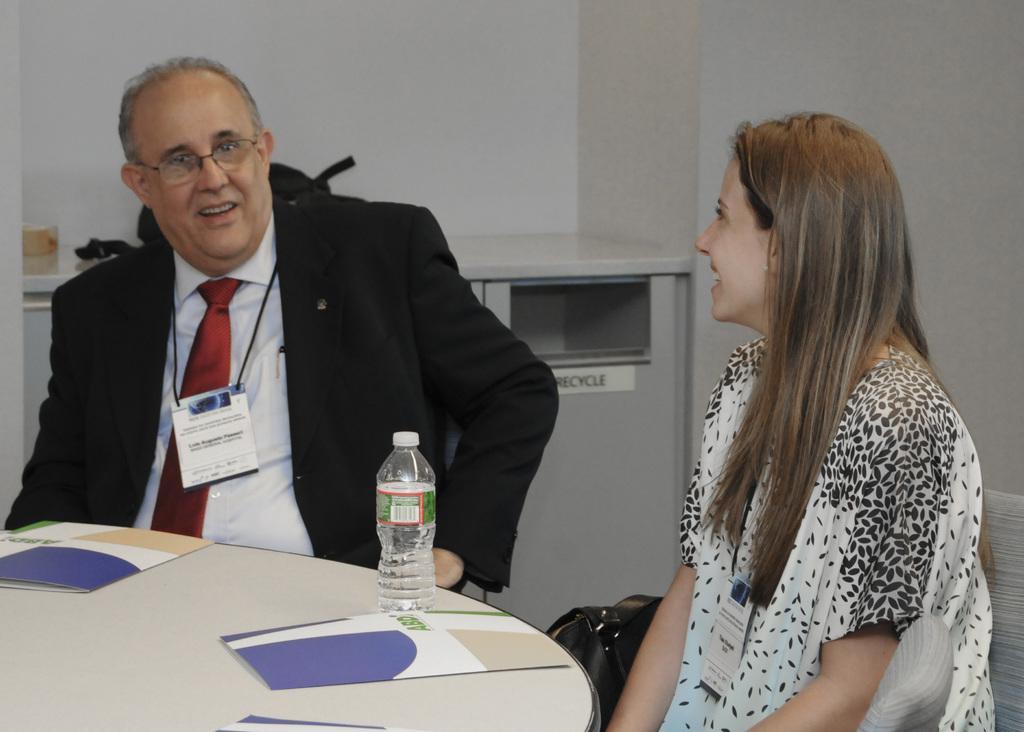Describe this image in one or two sentences. In this image there is a person sitting on chair is wearing suit and tie, spectacle. At the right side of the image there is a woman seeing at this man. Before them there is a table in which book and bottle is placed. Woman is having a bag beside her. At backside of them there is a table kept closer to the wall 